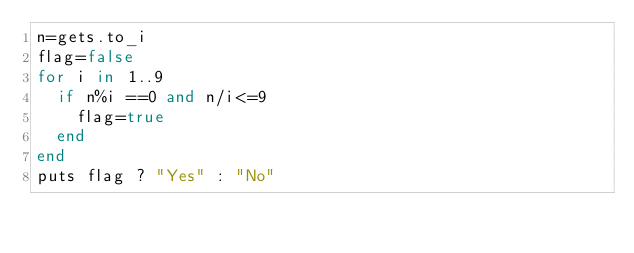<code> <loc_0><loc_0><loc_500><loc_500><_Ruby_>n=gets.to_i
flag=false
for i in 1..9
  if n%i ==0 and n/i<=9
    flag=true
  end
end
puts flag ? "Yes" : "No"
</code> 